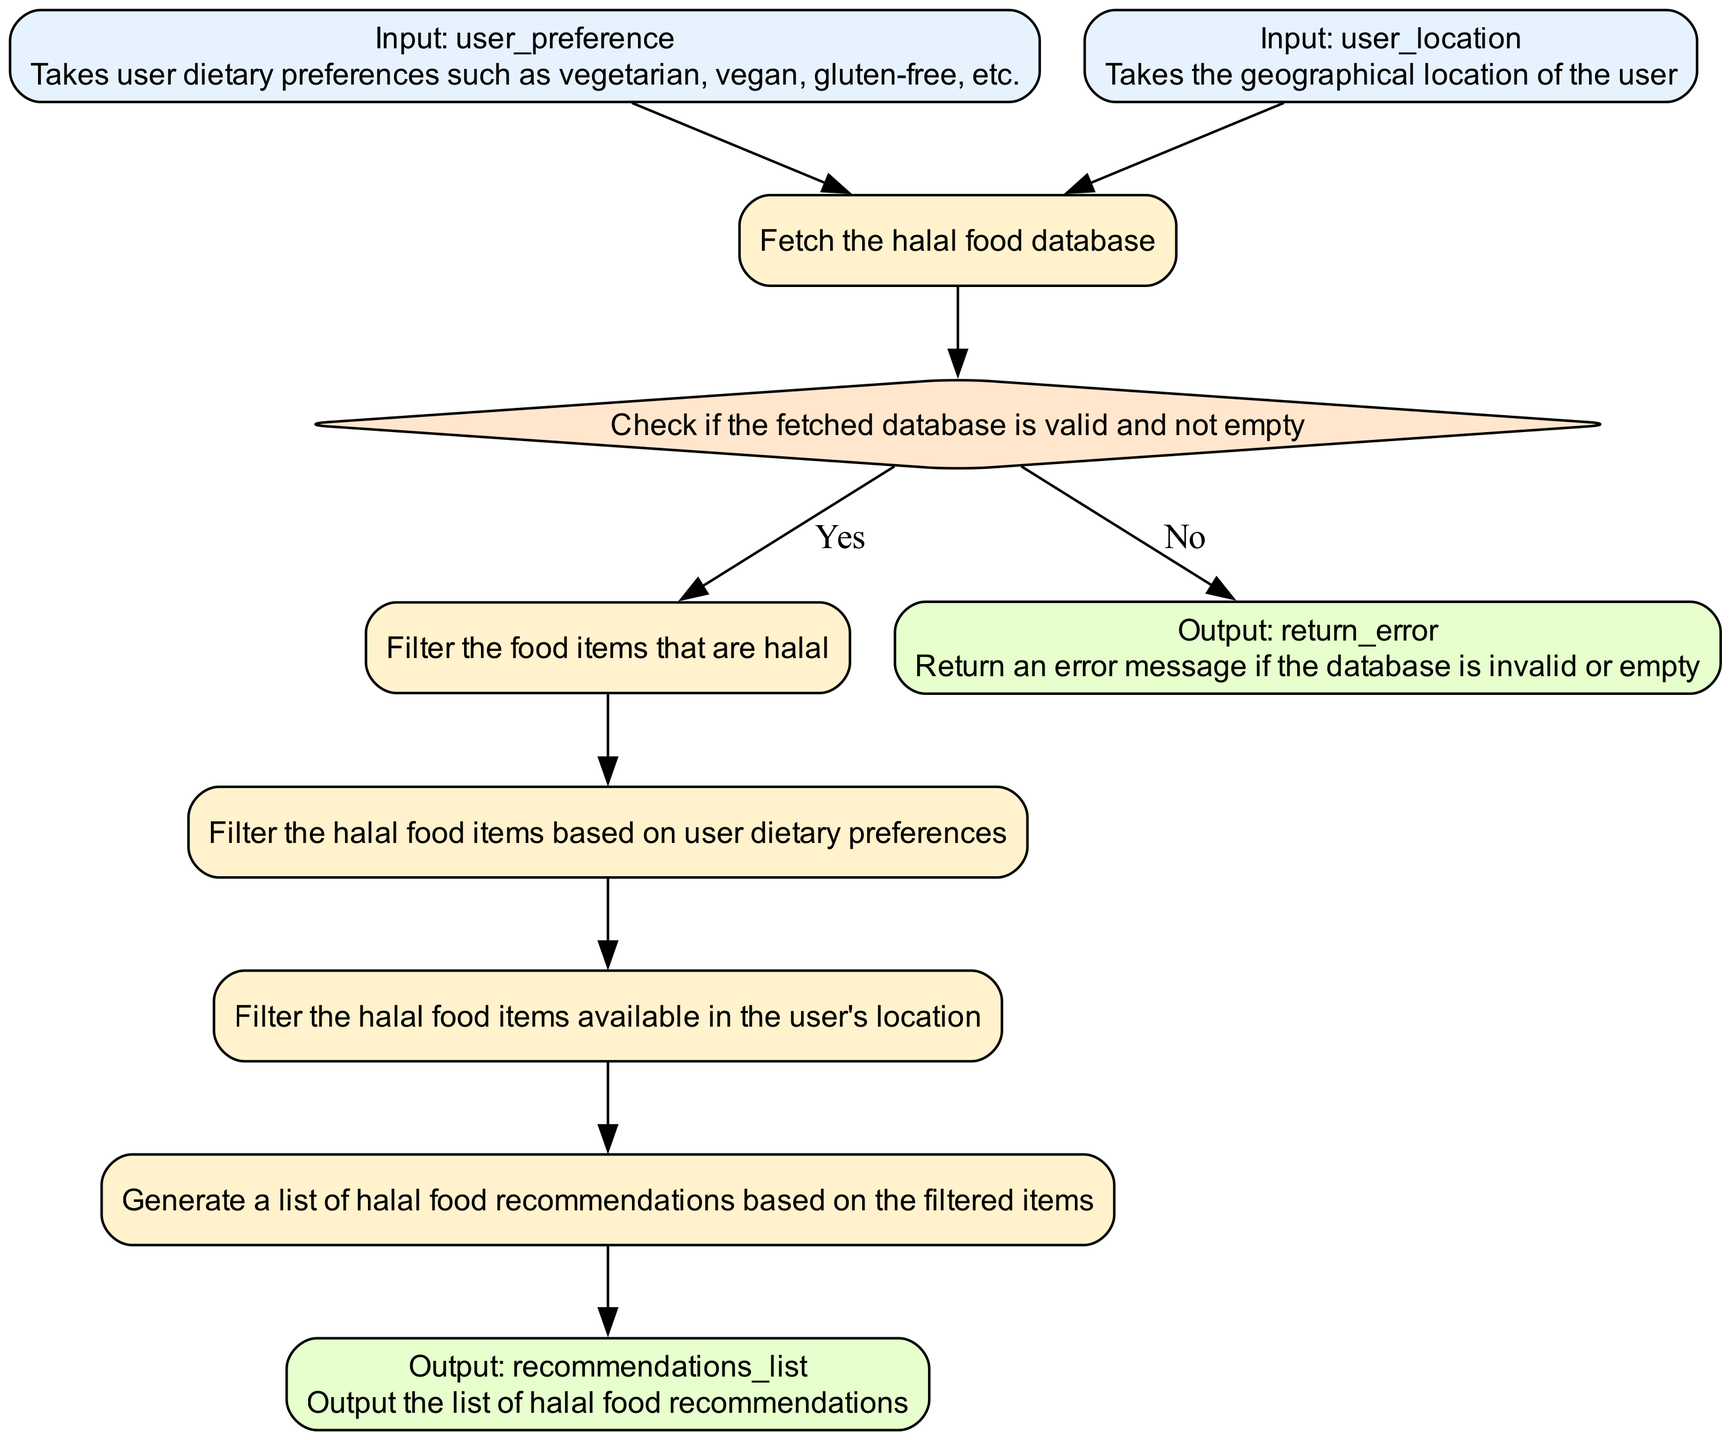What is the first input required by the function? The first input required by the function is user_preference, which takes user dietary preferences such as vegetarian, vegan, gluten-free, etc.
Answer: user_preference What type of node is 'check_validity'? The node 'check_validity' is of type decision, indicated by its diamond shape in the flowchart.
Answer: decision How many processes are there in the flowchart? The flowchart contains five process nodes: fetch_database, filter_halal_foods, filter_preferences, filter_location, and generate_recommendations.
Answer: five What happens if the database is invalid or empty? If the database is invalid or empty, the flowchart leads to the node labeled return_error, which outputs an error message.
Answer: return_error Which node follows 'filter_location'? The node that follows 'filter_location' is generate_recommendations, where the function generates a list of halal food recommendations based on the filtered items.
Answer: generate_recommendations What is filtered after halal foods? After filtering halal foods, the function filters based on user dietary preferences in the node labeled filter_preferences.
Answer: filter_preferences What nodes lead to 'recommendations_list'? The nodes that lead to 'recommendations_list' include filter_location, followed by generate_recommendations.
Answer: filter_location, generate_recommendations What type of output is provided by the node recommendations_list? The node recommendations_list provides an output detailing the list of halal food recommendations based on user preferences and location.
Answer: list of halal food recommendations What is the purpose of the node fetch_database? The purpose of the node fetch_database is to fetch the halal food database that is required for generating recommendations based on user inputs.
Answer: fetch the halal food database 